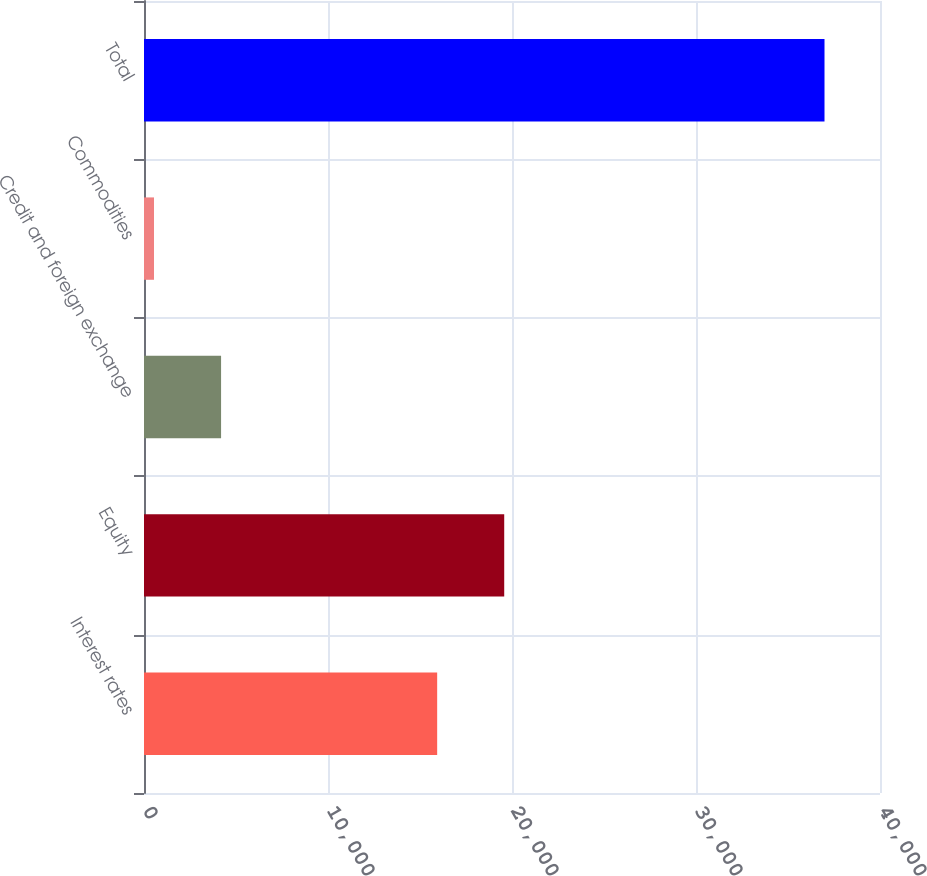Convert chart. <chart><loc_0><loc_0><loc_500><loc_500><bar_chart><fcel>Interest rates<fcel>Equity<fcel>Credit and foreign exchange<fcel>Commodities<fcel>Total<nl><fcel>15933<fcel>19576.9<fcel>4188.9<fcel>545<fcel>36984<nl></chart> 